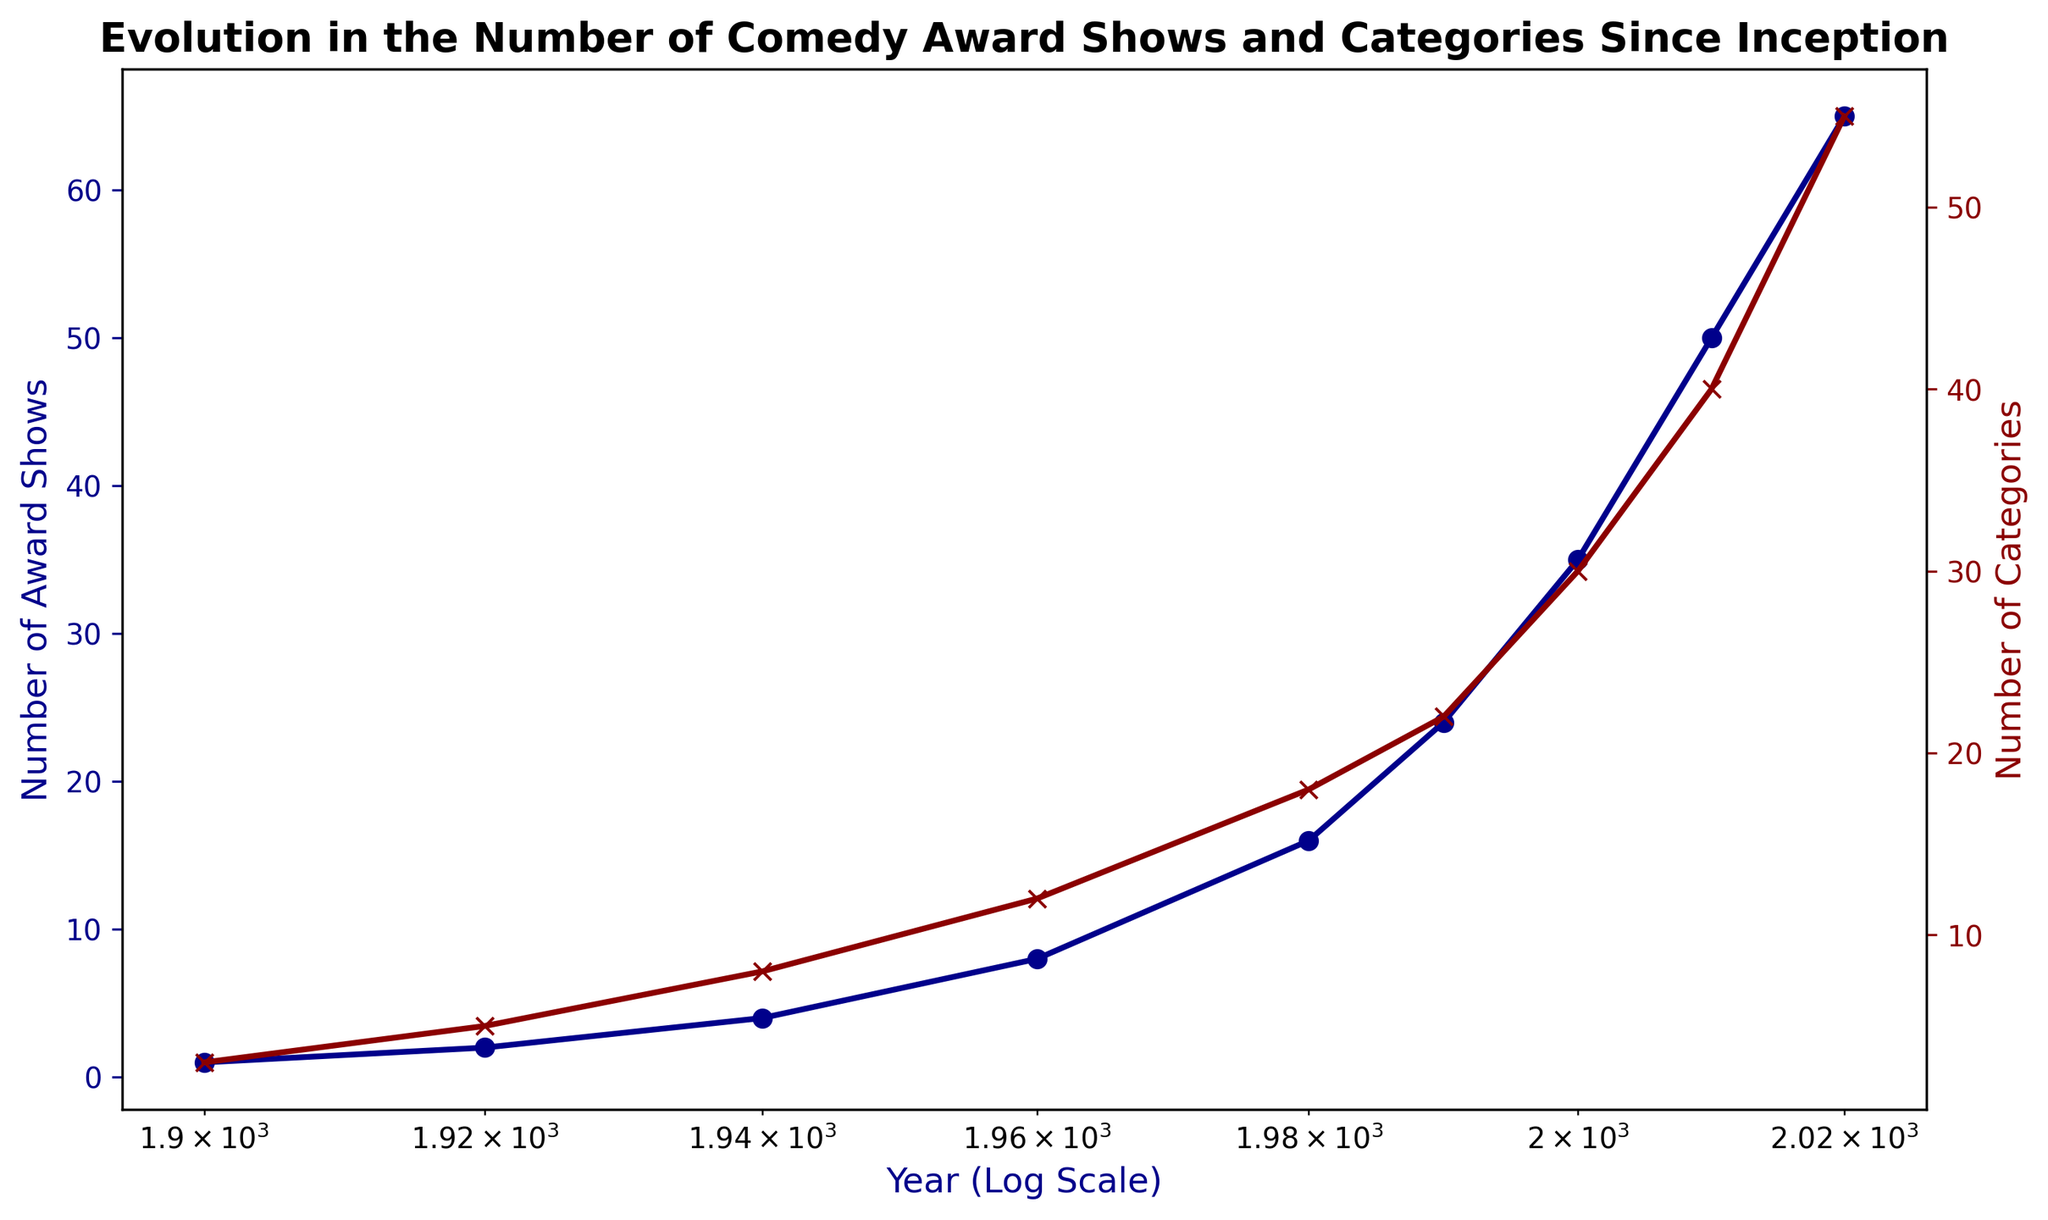What trends do we observe in the number of comedy award shows over the years? By looking at the blue line representing the number of award shows on the logscale x-axis, we notice a consistent increase from 1 show in 1900 to 65 shows in 2020, indicating a trend of growth over time.
Answer: Consistent growth How does the increase in the number of award shows compare with the increase in the number of categories? Both the number of award shows (blue line) and the number of categories (red line) increase over time, but the number of categories grows faster in more recent years, especially after 1980.
Answer: Categories grow faster Between which years did the number of comedy award shows experience the most significant increase? By examining the blue line, we see the steepest climb occurs between 1980 and 1990, where the number of award shows jumps from 16 to 24.
Answer: 1980 to 1990 How many more categories were there in 2020 compared to 1940? In 1940, there were 8 categories, and by 2020, there were 55. The difference is calculated as 55 - 8.
Answer: 47 At what points do the red and blue lines (representing categories and award shows, respectively) visibly diverge significantly? The lines start diverging significantly after 1980, where the red line (categories) begins to increase at a faster rate than the blue line (award shows).
Answer: After 1980 What is the ratio of the number of comedy award shows to the number of categories in 2010? In 2010, there were 50 award shows and 40 categories, giving a ratio of 50 to 40, which simplifies to 5:4.
Answer: 5:4 How does the doubling of the number of award shows relate to the doubling of categories? By observing the trends, the doubling of award shows roughly occurs every 20 years (1, 2, 4, 8, 16, 24, 50, 65). Categories also follow an accelerating trend, though not in exact doubling periods. Both have accelerated growth, but not strictly doubling.
Answer: Parallel growth Which year shows the closest similarity in the rate of increase for both datasets? The lines are moderately parallel in growth from 1960 to 1980, showing an increase of both shows (8 to 16 shows) and categories (12 to 18).
Answer: 1960 to 1980 